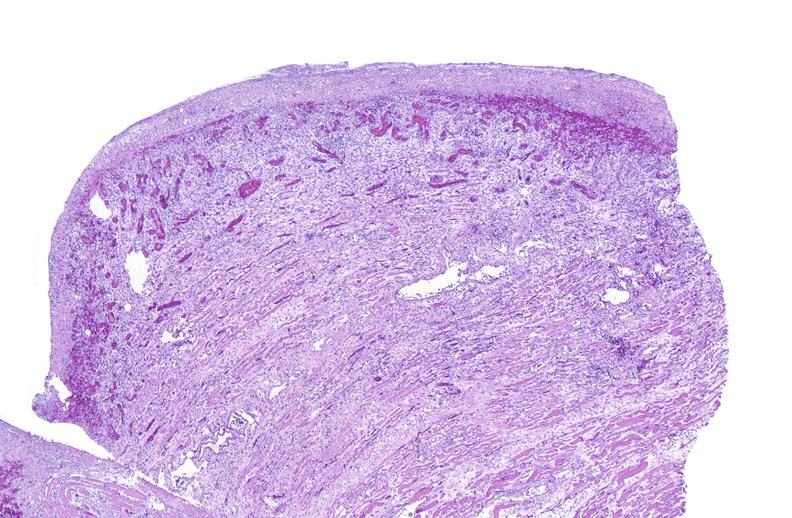s example present?
Answer the question using a single word or phrase. No 